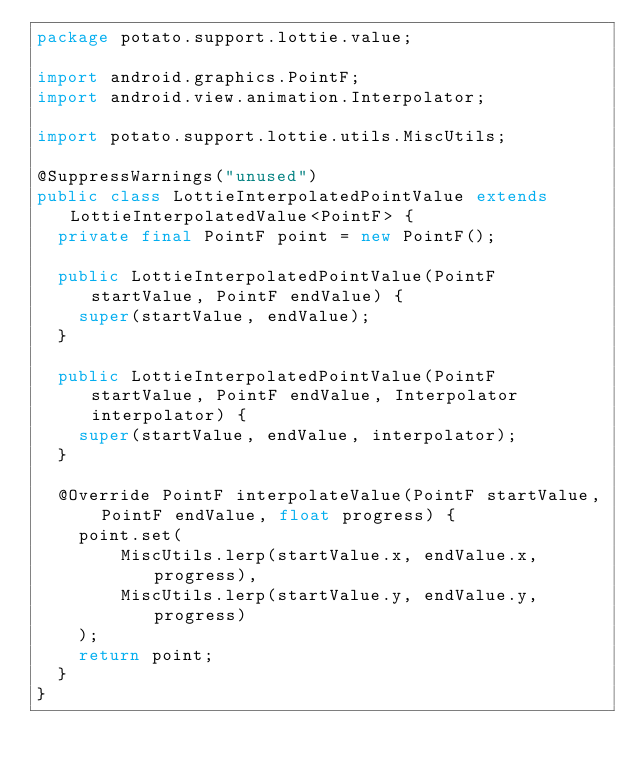Convert code to text. <code><loc_0><loc_0><loc_500><loc_500><_Java_>package potato.support.lottie.value;

import android.graphics.PointF;
import android.view.animation.Interpolator;

import potato.support.lottie.utils.MiscUtils;

@SuppressWarnings("unused")
public class LottieInterpolatedPointValue extends LottieInterpolatedValue<PointF> {
  private final PointF point = new PointF();

  public LottieInterpolatedPointValue(PointF startValue, PointF endValue) {
    super(startValue, endValue);
  }

  public LottieInterpolatedPointValue(PointF startValue, PointF endValue, Interpolator interpolator) {
    super(startValue, endValue, interpolator);
  }

  @Override PointF interpolateValue(PointF startValue, PointF endValue, float progress) {
    point.set(
        MiscUtils.lerp(startValue.x, endValue.x, progress),
        MiscUtils.lerp(startValue.y, endValue.y, progress)
    );
    return point;
  }
}
</code> 